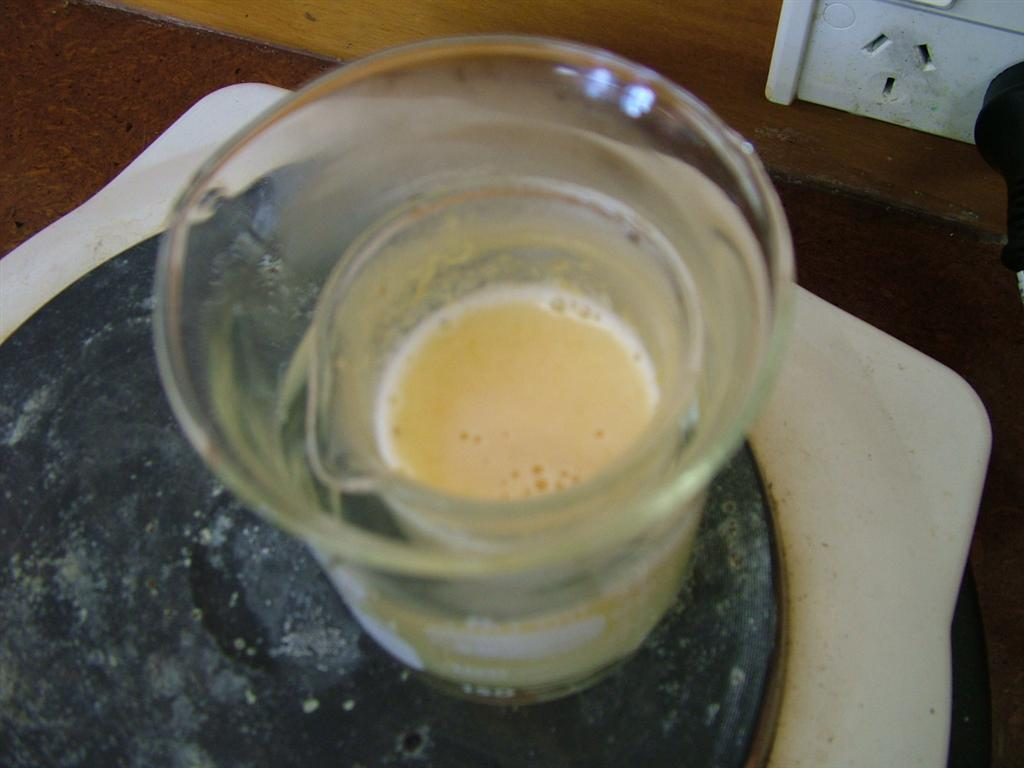What is the main subject of the image? The main subject of the image is a glass within a glass on a table. Can you describe the arrangement of the glasses? There is a glass within a glass on a table. What is visible in the background of the image? There is a switchboard on the wall in the background of the image. How many boys are present in the image? There are no boys present in the image; it only features a glass within a glass on a table and a switchboard on the wall. What type of spot can be seen on the glass? There is no spot visible on the glass in the image. 